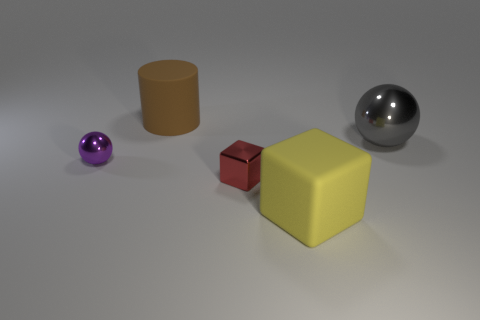What material is the sphere that is left of the large rubber object to the left of the yellow matte object?
Make the answer very short. Metal. What material is the other object that is the same shape as the big metal object?
Give a very brief answer. Metal. Are there any rubber things?
Your answer should be compact. Yes. What is the material of the cube in front of the small block?
Your answer should be compact. Rubber. How many big objects are either brown cylinders or blue metal objects?
Provide a succinct answer. 1. The metal cube is what color?
Provide a short and direct response. Red. There is a matte thing that is in front of the big cylinder; are there any yellow cubes in front of it?
Ensure brevity in your answer.  No. Are there fewer yellow things that are in front of the big cylinder than balls?
Offer a terse response. Yes. Is the material of the tiny thing to the right of the purple ball the same as the large gray thing?
Your response must be concise. Yes. The cylinder that is the same material as the large yellow block is what color?
Make the answer very short. Brown. 